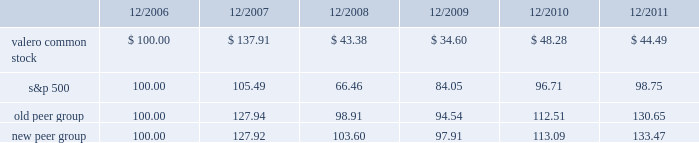Table of contents the following performance graph is not 201csoliciting material , 201d is not deemed filed with the sec , and is not to be incorporated by reference into any of valero 2019s filings under the securities act of 1933 or the securities exchange act of 1934 , as amended , respectively .
This performance graph and the related textual information are based on historical data and are not indicative of future performance .
The following line graph compares the cumulative total return 1 on an investment in our common stock against the cumulative total return of the s&p 500 composite index and an index of peer companies ( that we selected ) for the five-year period commencing december 31 , 2006 and ending december 31 , 2011 .
Our peer group consists of the following nine companies that are engaged in refining operations in the u.s. : alon usa energy , inc. ; chevron corporation ; cvr energy , inc. ; exxon mobil corporation ; hess corporation ; hollyfrontier corporation ; marathon petroleum corporation ; tesoro corporation ; and western refining , inc .
Our peer group previously included conocophillips ; marathon oil corporation ; murphy oil corporation ; and sunoco , inc. , but they are not included in our current peer group because they have exited or are exiting refining operations in the u.s .
Frontier oil corporation and holly corporation are now represented in our peer group as hollyfrontier corporation. .
1 assumes that an investment in valero common stock and each index was $ 100 on december 31 , 2006 .
201ccumulative total return 201d is based on share price appreciation plus reinvestment of dividends from december 31 , 2006 through december 31 , 2011. .
What was the range for valero stock from 2007-2011? 
Computations: (137.91 - 34.60)
Answer: 103.31. 